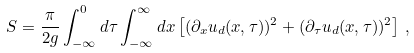<formula> <loc_0><loc_0><loc_500><loc_500>S = \frac { \pi } { 2 g } \int _ { - \infty } ^ { 0 } d \tau \int _ { - \infty } ^ { \infty } d x \left [ ( \partial _ { x } u _ { d } ( x , \tau ) ) ^ { 2 } + ( \partial _ { \tau } u _ { d } ( x , \tau ) ) ^ { 2 } \right ] \, ,</formula> 